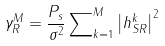Convert formula to latex. <formula><loc_0><loc_0><loc_500><loc_500>{ \gamma _ { R } ^ { M } } = \frac { P _ { s } } { \sigma ^ { 2 } } \sum \nolimits _ { k = 1 } ^ { M } { { { \left | { h _ { S R } ^ { k } } \right | } ^ { 2 } } }</formula> 